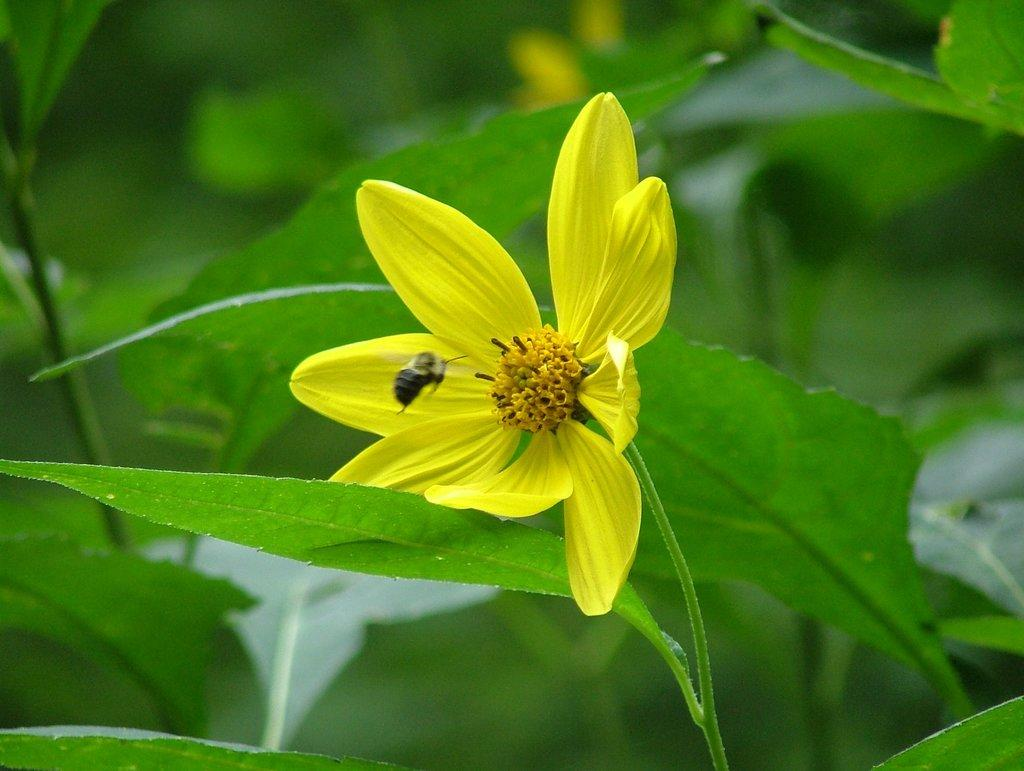What type of flower is in the image? There is a yellow flower in the image. What is in front of the flower? There is an insect in front of the flower. What is located behind the flower? There are leaves behind the flower. How would you describe the background of the image? The background of the image is blurred. What type of advertisement can be seen on the flower in the image? There is no advertisement present on the flower in the image. Is the flower poisonous, and if so, how can it be identified? The facts provided do not mention whether the flower is poisonous or not, and there is no information to identify it as such. 